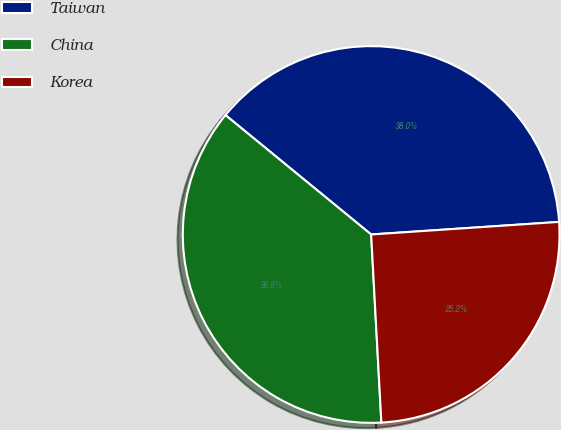Convert chart. <chart><loc_0><loc_0><loc_500><loc_500><pie_chart><fcel>Taiwan<fcel>China<fcel>Korea<nl><fcel>38.01%<fcel>36.79%<fcel>25.2%<nl></chart> 